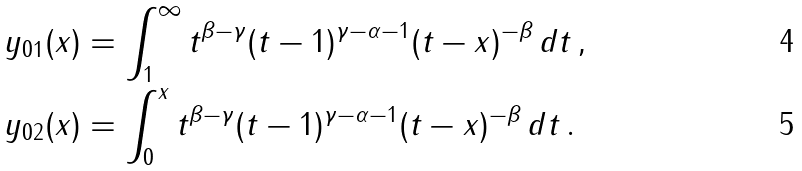<formula> <loc_0><loc_0><loc_500><loc_500>y _ { 0 1 } ( x ) & = \int _ { 1 } ^ { \infty } t ^ { \beta - \gamma } ( t - 1 ) ^ { \gamma - \alpha - 1 } ( t - x ) ^ { - \beta } \, d t \, , \\ y _ { 0 2 } ( x ) & = \int _ { 0 } ^ { x } t ^ { \beta - \gamma } ( t - 1 ) ^ { \gamma - \alpha - 1 } ( t - x ) ^ { - \beta } \, d t \, .</formula> 